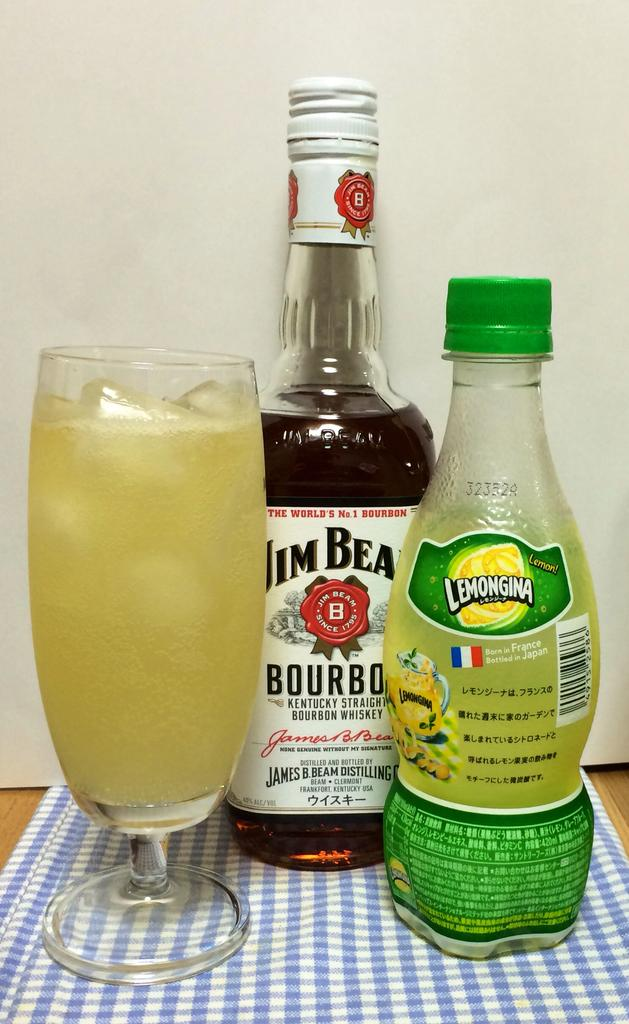<image>
Create a compact narrative representing the image presented. A bottle of Jim Beam is next to a bottle of Lemon Juice and a glass. 